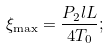Convert formula to latex. <formula><loc_0><loc_0><loc_500><loc_500>\xi _ { \max } = \frac { P _ { 2 } l L } { 4 T _ { 0 } } ;</formula> 